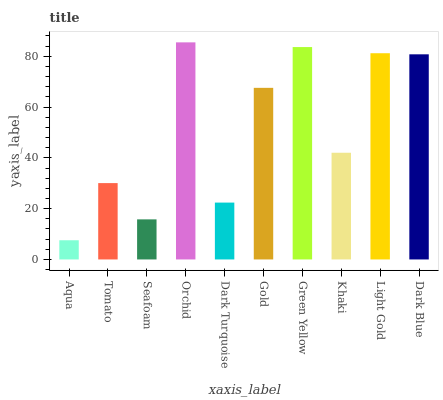Is Aqua the minimum?
Answer yes or no. Yes. Is Orchid the maximum?
Answer yes or no. Yes. Is Tomato the minimum?
Answer yes or no. No. Is Tomato the maximum?
Answer yes or no. No. Is Tomato greater than Aqua?
Answer yes or no. Yes. Is Aqua less than Tomato?
Answer yes or no. Yes. Is Aqua greater than Tomato?
Answer yes or no. No. Is Tomato less than Aqua?
Answer yes or no. No. Is Gold the high median?
Answer yes or no. Yes. Is Khaki the low median?
Answer yes or no. Yes. Is Green Yellow the high median?
Answer yes or no. No. Is Orchid the low median?
Answer yes or no. No. 